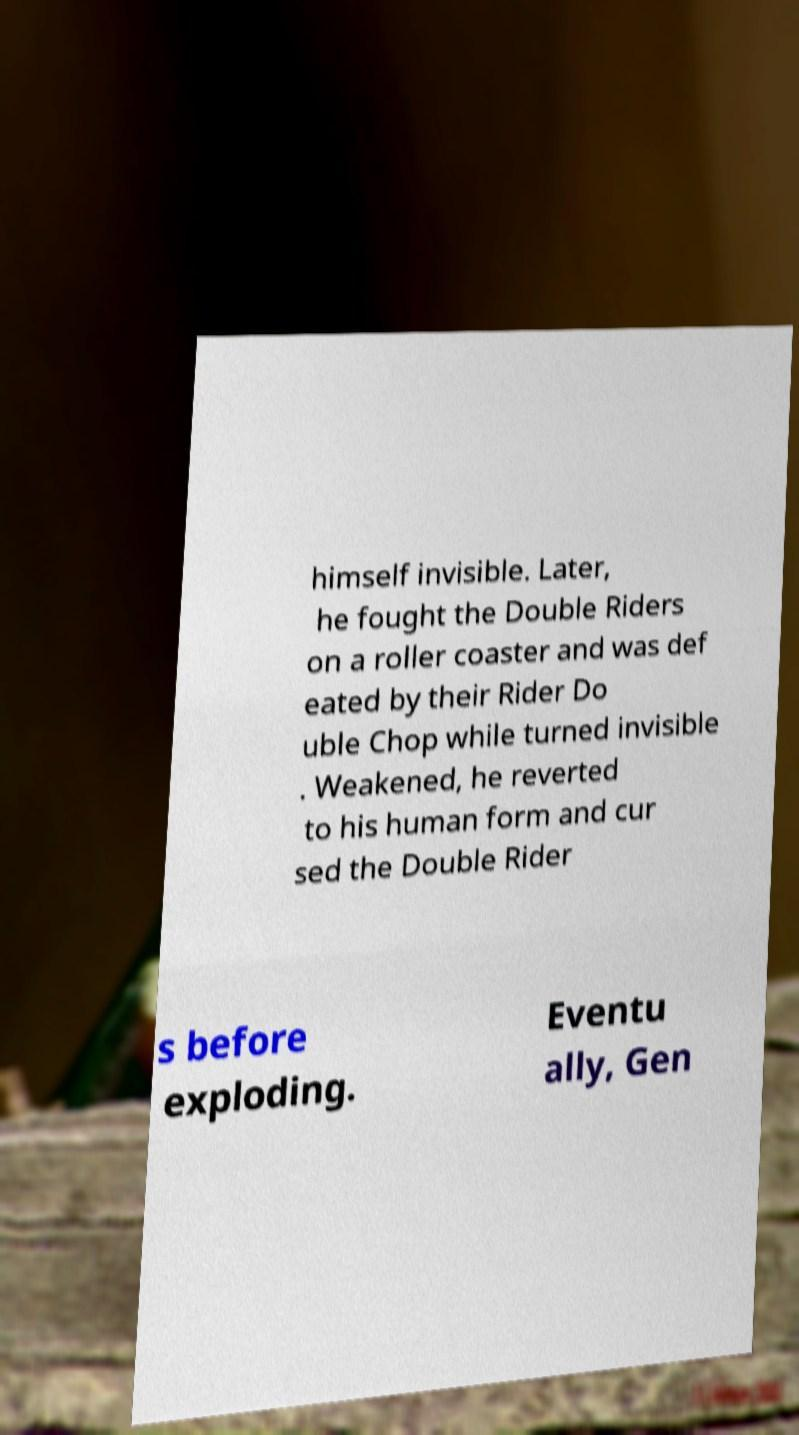Could you extract and type out the text from this image? himself invisible. Later, he fought the Double Riders on a roller coaster and was def eated by their Rider Do uble Chop while turned invisible . Weakened, he reverted to his human form and cur sed the Double Rider s before exploding. Eventu ally, Gen 